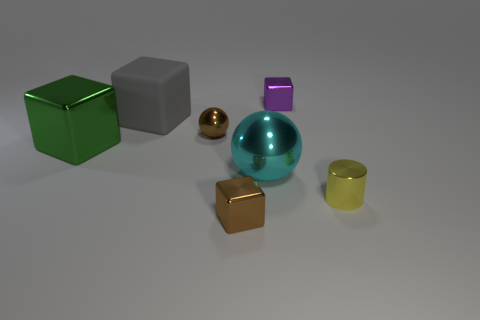Subtract all tiny purple cubes. How many cubes are left? 3 Add 2 metal spheres. How many objects exist? 9 Subtract all green cubes. How many cubes are left? 3 Subtract 1 balls. How many balls are left? 1 Subtract all spheres. How many objects are left? 5 Subtract all brown cylinders. How many brown spheres are left? 1 Subtract all tiny blocks. Subtract all green objects. How many objects are left? 4 Add 4 metal cylinders. How many metal cylinders are left? 5 Add 5 tiny metal cylinders. How many tiny metal cylinders exist? 6 Subtract 0 green cylinders. How many objects are left? 7 